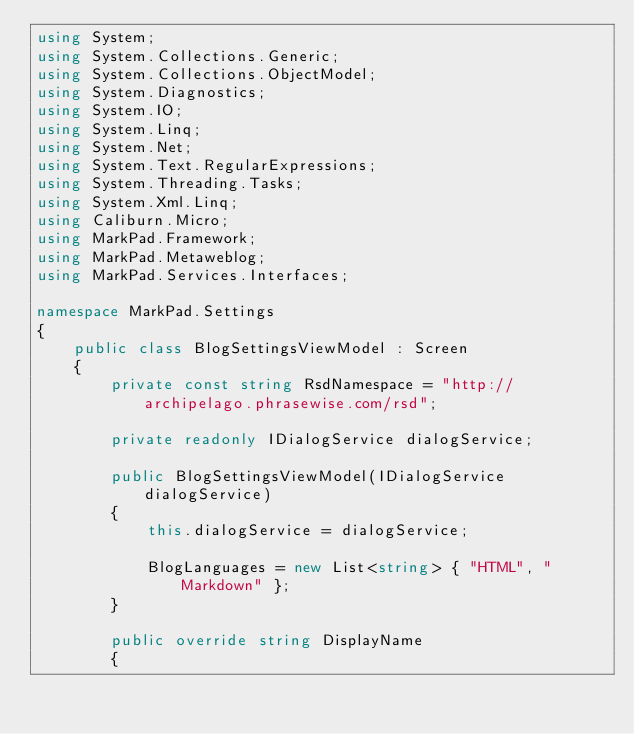<code> <loc_0><loc_0><loc_500><loc_500><_C#_>using System;
using System.Collections.Generic;
using System.Collections.ObjectModel;
using System.Diagnostics;
using System.IO;
using System.Linq;
using System.Net;
using System.Text.RegularExpressions;
using System.Threading.Tasks;
using System.Xml.Linq;
using Caliburn.Micro;
using MarkPad.Framework;
using MarkPad.Metaweblog;
using MarkPad.Services.Interfaces;

namespace MarkPad.Settings
{
    public class BlogSettingsViewModel : Screen
    {
        private const string RsdNamespace = "http://archipelago.phrasewise.com/rsd";
        
        private readonly IDialogService dialogService;

        public BlogSettingsViewModel(IDialogService dialogService)
        {
            this.dialogService = dialogService;

            BlogLanguages = new List<string> { "HTML", "Markdown" };
        }

        public override string DisplayName
        {</code> 